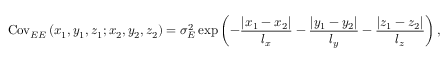Convert formula to latex. <formula><loc_0><loc_0><loc_500><loc_500>C o v _ { E E } \left ( x _ { 1 } , y _ { 1 } , z _ { 1 } ; x _ { 2 } , y _ { 2 } , z _ { 2 } \right ) = \sigma _ { E } ^ { 2 } \exp \left ( { - \frac { { \left | x _ { 1 } - x _ { 2 } \right | } } { l _ { x } } - \frac { { \left | y _ { 1 } - y _ { 2 } \right | } } { l _ { y } } - \frac { { \left | z _ { 1 } - z _ { 2 } \right | } } { l _ { z } } } \right ) ,</formula> 